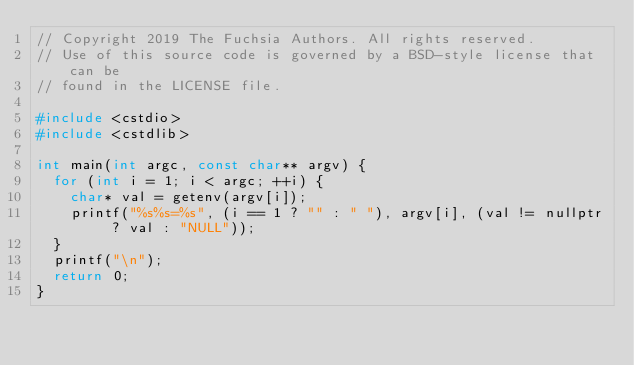Convert code to text. <code><loc_0><loc_0><loc_500><loc_500><_C++_>// Copyright 2019 The Fuchsia Authors. All rights reserved.
// Use of this source code is governed by a BSD-style license that can be
// found in the LICENSE file.

#include <cstdio>
#include <cstdlib>

int main(int argc, const char** argv) {
  for (int i = 1; i < argc; ++i) {
    char* val = getenv(argv[i]);
    printf("%s%s=%s", (i == 1 ? "" : " "), argv[i], (val != nullptr ? val : "NULL"));
  }
  printf("\n");
  return 0;
}
</code> 